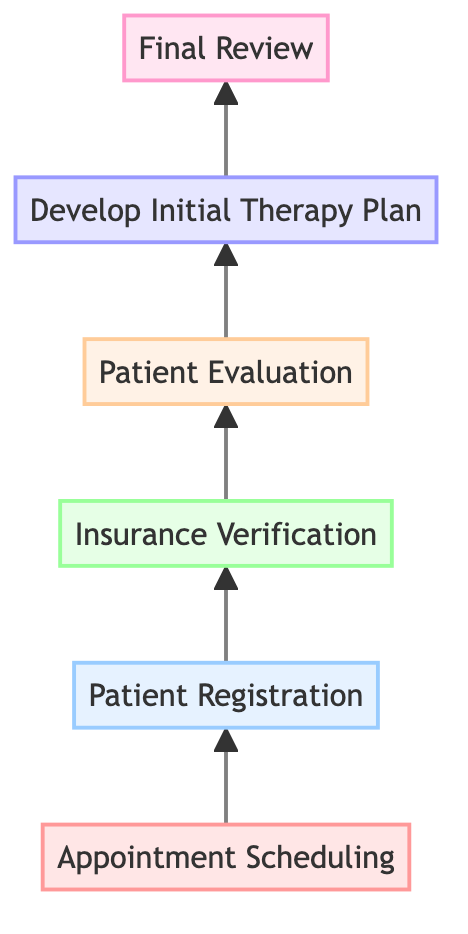What is the first step in the Patient Intake Process for Physical Therapy? The first step is indicated at the bottom of the flow chart, which shows "Appointment Scheduling" as the initial action in the process.
Answer: Appointment Scheduling How many steps are there in the Patient Intake Process? Counting each of the steps listed in the flow chart, there are a total of six distinct steps from appointment scheduling to final review.
Answer: 6 What step comes directly after "Patient Registration"? Following the flow from the "Patient Registration" node, the next step indicated in the chart is "Insurance Verification."
Answer: Insurance Verification What is the last step in the Patient Intake Process? The flow chart shows that the final action in the process, located at the top, is "Final Review."
Answer: Final Review Which step includes evaluating strength, flexibility, and range of motion? The node corresponding to the step that includes conducting a thorough evaluation, which specifically mentions these assessments, is "Patient Evaluation."
Answer: Patient Evaluation What is the relationship between "Insurance Verification" and "Patient Evaluation"? The flow chart shows a direct connection where "Insurance Verification" precedes "Patient Evaluation," indicating that the verification step must be completed before proceeding to the evaluation.
Answer: Insurance Verification leads to Patient Evaluation What is developed during the 5th step? The description of the fifth step refers to creating a tailored plan based on the patient's needs and goals, which is termed the "Initial Therapy Plan."
Answer: Initial Therapy Plan Explain the significance of the "Final Review" step. The last step is crucial as it serves to finalize and verify all patient information, ensuring accuracy in assessments and insurance details, which is key for patient care.
Answer: Verify all information What is the purpose of the "Patient Registration" step? The "Patient Registration" step's function is to gather essential personal information about the patient, setting the foundation for the intake process.
Answer: Collect personal information 